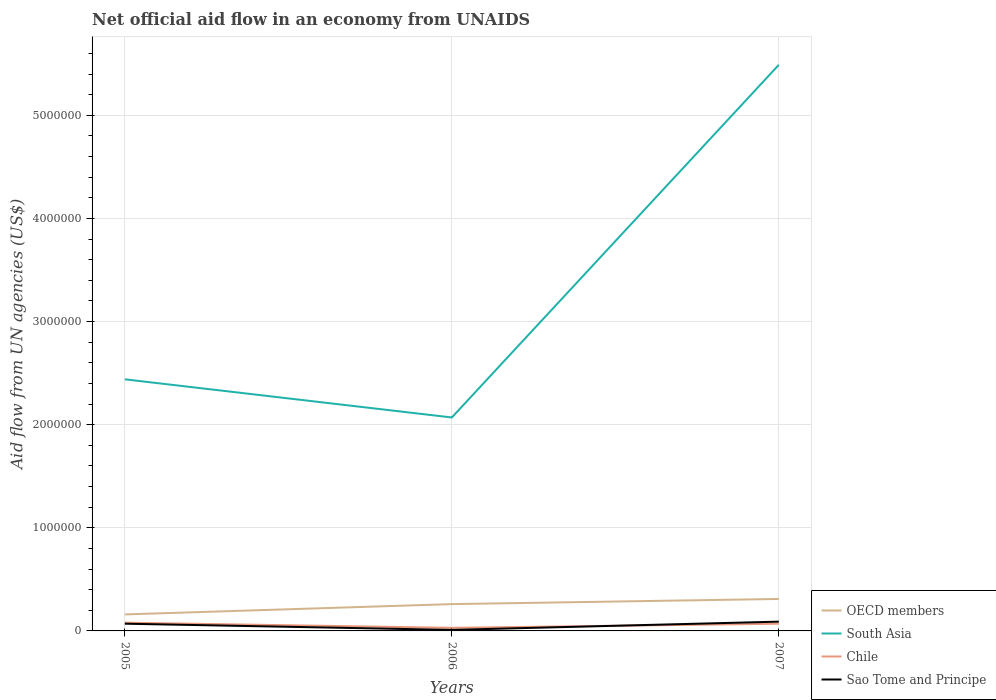Is the number of lines equal to the number of legend labels?
Offer a very short reply. Yes. Across all years, what is the maximum net official aid flow in OECD members?
Your response must be concise. 1.60e+05. In which year was the net official aid flow in OECD members maximum?
Your response must be concise. 2005. What is the total net official aid flow in Chile in the graph?
Ensure brevity in your answer.  -4.00e+04. What is the difference between the highest and the second highest net official aid flow in South Asia?
Provide a short and direct response. 3.42e+06. How many lines are there?
Keep it short and to the point. 4. Does the graph contain grids?
Provide a short and direct response. Yes. How many legend labels are there?
Your answer should be very brief. 4. How are the legend labels stacked?
Your response must be concise. Vertical. What is the title of the graph?
Make the answer very short. Net official aid flow in an economy from UNAIDS. Does "Cambodia" appear as one of the legend labels in the graph?
Ensure brevity in your answer.  No. What is the label or title of the X-axis?
Your response must be concise. Years. What is the label or title of the Y-axis?
Offer a terse response. Aid flow from UN agencies (US$). What is the Aid flow from UN agencies (US$) of South Asia in 2005?
Your answer should be very brief. 2.44e+06. What is the Aid flow from UN agencies (US$) in Chile in 2005?
Your answer should be compact. 8.00e+04. What is the Aid flow from UN agencies (US$) in OECD members in 2006?
Provide a short and direct response. 2.60e+05. What is the Aid flow from UN agencies (US$) of South Asia in 2006?
Give a very brief answer. 2.07e+06. What is the Aid flow from UN agencies (US$) in Chile in 2006?
Your response must be concise. 3.00e+04. What is the Aid flow from UN agencies (US$) of OECD members in 2007?
Offer a terse response. 3.10e+05. What is the Aid flow from UN agencies (US$) in South Asia in 2007?
Your answer should be very brief. 5.49e+06. What is the Aid flow from UN agencies (US$) in Chile in 2007?
Give a very brief answer. 7.00e+04. What is the Aid flow from UN agencies (US$) in Sao Tome and Principe in 2007?
Keep it short and to the point. 9.00e+04. Across all years, what is the maximum Aid flow from UN agencies (US$) of OECD members?
Ensure brevity in your answer.  3.10e+05. Across all years, what is the maximum Aid flow from UN agencies (US$) in South Asia?
Provide a short and direct response. 5.49e+06. Across all years, what is the maximum Aid flow from UN agencies (US$) in Chile?
Give a very brief answer. 8.00e+04. Across all years, what is the maximum Aid flow from UN agencies (US$) in Sao Tome and Principe?
Give a very brief answer. 9.00e+04. Across all years, what is the minimum Aid flow from UN agencies (US$) in OECD members?
Provide a short and direct response. 1.60e+05. Across all years, what is the minimum Aid flow from UN agencies (US$) of South Asia?
Ensure brevity in your answer.  2.07e+06. Across all years, what is the minimum Aid flow from UN agencies (US$) in Sao Tome and Principe?
Provide a succinct answer. 10000. What is the total Aid flow from UN agencies (US$) in OECD members in the graph?
Give a very brief answer. 7.30e+05. What is the total Aid flow from UN agencies (US$) of Chile in the graph?
Give a very brief answer. 1.80e+05. What is the total Aid flow from UN agencies (US$) in Sao Tome and Principe in the graph?
Your response must be concise. 1.70e+05. What is the difference between the Aid flow from UN agencies (US$) in South Asia in 2005 and that in 2006?
Provide a short and direct response. 3.70e+05. What is the difference between the Aid flow from UN agencies (US$) of Chile in 2005 and that in 2006?
Provide a short and direct response. 5.00e+04. What is the difference between the Aid flow from UN agencies (US$) of Sao Tome and Principe in 2005 and that in 2006?
Give a very brief answer. 6.00e+04. What is the difference between the Aid flow from UN agencies (US$) of OECD members in 2005 and that in 2007?
Your answer should be compact. -1.50e+05. What is the difference between the Aid flow from UN agencies (US$) in South Asia in 2005 and that in 2007?
Keep it short and to the point. -3.05e+06. What is the difference between the Aid flow from UN agencies (US$) in Chile in 2005 and that in 2007?
Keep it short and to the point. 10000. What is the difference between the Aid flow from UN agencies (US$) in Sao Tome and Principe in 2005 and that in 2007?
Your answer should be compact. -2.00e+04. What is the difference between the Aid flow from UN agencies (US$) in OECD members in 2006 and that in 2007?
Your answer should be very brief. -5.00e+04. What is the difference between the Aid flow from UN agencies (US$) in South Asia in 2006 and that in 2007?
Your answer should be compact. -3.42e+06. What is the difference between the Aid flow from UN agencies (US$) of OECD members in 2005 and the Aid flow from UN agencies (US$) of South Asia in 2006?
Offer a very short reply. -1.91e+06. What is the difference between the Aid flow from UN agencies (US$) in South Asia in 2005 and the Aid flow from UN agencies (US$) in Chile in 2006?
Provide a short and direct response. 2.41e+06. What is the difference between the Aid flow from UN agencies (US$) in South Asia in 2005 and the Aid flow from UN agencies (US$) in Sao Tome and Principe in 2006?
Ensure brevity in your answer.  2.43e+06. What is the difference between the Aid flow from UN agencies (US$) of OECD members in 2005 and the Aid flow from UN agencies (US$) of South Asia in 2007?
Ensure brevity in your answer.  -5.33e+06. What is the difference between the Aid flow from UN agencies (US$) in South Asia in 2005 and the Aid flow from UN agencies (US$) in Chile in 2007?
Provide a short and direct response. 2.37e+06. What is the difference between the Aid flow from UN agencies (US$) of South Asia in 2005 and the Aid flow from UN agencies (US$) of Sao Tome and Principe in 2007?
Provide a succinct answer. 2.35e+06. What is the difference between the Aid flow from UN agencies (US$) in Chile in 2005 and the Aid flow from UN agencies (US$) in Sao Tome and Principe in 2007?
Offer a terse response. -10000. What is the difference between the Aid flow from UN agencies (US$) in OECD members in 2006 and the Aid flow from UN agencies (US$) in South Asia in 2007?
Make the answer very short. -5.23e+06. What is the difference between the Aid flow from UN agencies (US$) in South Asia in 2006 and the Aid flow from UN agencies (US$) in Sao Tome and Principe in 2007?
Your answer should be compact. 1.98e+06. What is the average Aid flow from UN agencies (US$) of OECD members per year?
Make the answer very short. 2.43e+05. What is the average Aid flow from UN agencies (US$) in South Asia per year?
Your response must be concise. 3.33e+06. What is the average Aid flow from UN agencies (US$) in Chile per year?
Your answer should be very brief. 6.00e+04. What is the average Aid flow from UN agencies (US$) in Sao Tome and Principe per year?
Your answer should be compact. 5.67e+04. In the year 2005, what is the difference between the Aid flow from UN agencies (US$) in OECD members and Aid flow from UN agencies (US$) in South Asia?
Provide a short and direct response. -2.28e+06. In the year 2005, what is the difference between the Aid flow from UN agencies (US$) of South Asia and Aid flow from UN agencies (US$) of Chile?
Keep it short and to the point. 2.36e+06. In the year 2005, what is the difference between the Aid flow from UN agencies (US$) in South Asia and Aid flow from UN agencies (US$) in Sao Tome and Principe?
Your answer should be very brief. 2.37e+06. In the year 2006, what is the difference between the Aid flow from UN agencies (US$) in OECD members and Aid flow from UN agencies (US$) in South Asia?
Keep it short and to the point. -1.81e+06. In the year 2006, what is the difference between the Aid flow from UN agencies (US$) of OECD members and Aid flow from UN agencies (US$) of Chile?
Your answer should be compact. 2.30e+05. In the year 2006, what is the difference between the Aid flow from UN agencies (US$) of South Asia and Aid flow from UN agencies (US$) of Chile?
Your answer should be very brief. 2.04e+06. In the year 2006, what is the difference between the Aid flow from UN agencies (US$) of South Asia and Aid flow from UN agencies (US$) of Sao Tome and Principe?
Offer a very short reply. 2.06e+06. In the year 2007, what is the difference between the Aid flow from UN agencies (US$) of OECD members and Aid flow from UN agencies (US$) of South Asia?
Give a very brief answer. -5.18e+06. In the year 2007, what is the difference between the Aid flow from UN agencies (US$) in OECD members and Aid flow from UN agencies (US$) in Chile?
Your answer should be very brief. 2.40e+05. In the year 2007, what is the difference between the Aid flow from UN agencies (US$) of South Asia and Aid flow from UN agencies (US$) of Chile?
Offer a very short reply. 5.42e+06. In the year 2007, what is the difference between the Aid flow from UN agencies (US$) in South Asia and Aid flow from UN agencies (US$) in Sao Tome and Principe?
Ensure brevity in your answer.  5.40e+06. In the year 2007, what is the difference between the Aid flow from UN agencies (US$) of Chile and Aid flow from UN agencies (US$) of Sao Tome and Principe?
Your answer should be compact. -2.00e+04. What is the ratio of the Aid flow from UN agencies (US$) of OECD members in 2005 to that in 2006?
Make the answer very short. 0.62. What is the ratio of the Aid flow from UN agencies (US$) of South Asia in 2005 to that in 2006?
Offer a very short reply. 1.18. What is the ratio of the Aid flow from UN agencies (US$) in Chile in 2005 to that in 2006?
Make the answer very short. 2.67. What is the ratio of the Aid flow from UN agencies (US$) in Sao Tome and Principe in 2005 to that in 2006?
Your response must be concise. 7. What is the ratio of the Aid flow from UN agencies (US$) of OECD members in 2005 to that in 2007?
Your answer should be compact. 0.52. What is the ratio of the Aid flow from UN agencies (US$) in South Asia in 2005 to that in 2007?
Provide a short and direct response. 0.44. What is the ratio of the Aid flow from UN agencies (US$) of OECD members in 2006 to that in 2007?
Offer a terse response. 0.84. What is the ratio of the Aid flow from UN agencies (US$) in South Asia in 2006 to that in 2007?
Offer a terse response. 0.38. What is the ratio of the Aid flow from UN agencies (US$) of Chile in 2006 to that in 2007?
Keep it short and to the point. 0.43. What is the ratio of the Aid flow from UN agencies (US$) of Sao Tome and Principe in 2006 to that in 2007?
Keep it short and to the point. 0.11. What is the difference between the highest and the second highest Aid flow from UN agencies (US$) of South Asia?
Provide a succinct answer. 3.05e+06. What is the difference between the highest and the second highest Aid flow from UN agencies (US$) of Sao Tome and Principe?
Your answer should be compact. 2.00e+04. What is the difference between the highest and the lowest Aid flow from UN agencies (US$) of South Asia?
Keep it short and to the point. 3.42e+06. What is the difference between the highest and the lowest Aid flow from UN agencies (US$) in Sao Tome and Principe?
Offer a very short reply. 8.00e+04. 